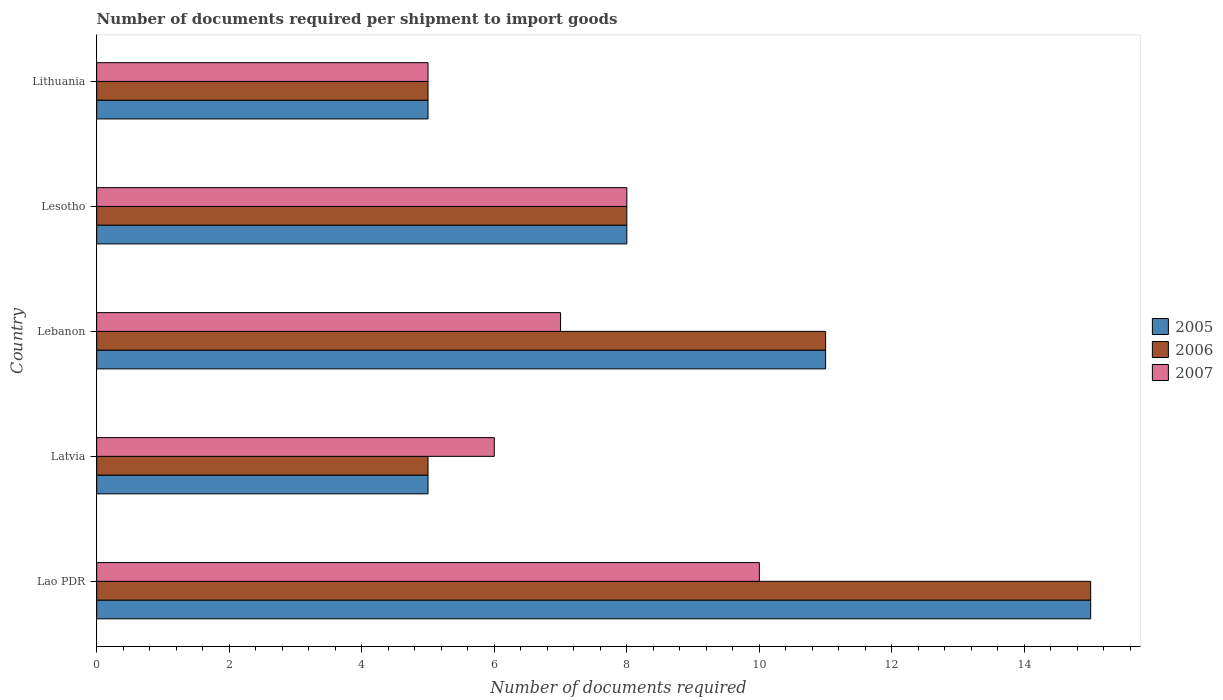How many groups of bars are there?
Keep it short and to the point. 5. How many bars are there on the 4th tick from the top?
Ensure brevity in your answer.  3. What is the label of the 1st group of bars from the top?
Your answer should be compact. Lithuania. In which country was the number of documents required per shipment to import goods in 2006 maximum?
Make the answer very short. Lao PDR. In which country was the number of documents required per shipment to import goods in 2005 minimum?
Offer a very short reply. Latvia. What is the total number of documents required per shipment to import goods in 2007 in the graph?
Your response must be concise. 36. What is the difference between the number of documents required per shipment to import goods in 2005 in Latvia and that in Lithuania?
Ensure brevity in your answer.  0. What is the difference between the number of documents required per shipment to import goods in 2007 in Lao PDR and the number of documents required per shipment to import goods in 2006 in Latvia?
Keep it short and to the point. 5. What is the average number of documents required per shipment to import goods in 2007 per country?
Offer a terse response. 7.2. What is the ratio of the number of documents required per shipment to import goods in 2005 in Latvia to that in Lithuania?
Offer a very short reply. 1. Is the difference between the number of documents required per shipment to import goods in 2006 in Latvia and Lesotho greater than the difference between the number of documents required per shipment to import goods in 2005 in Latvia and Lesotho?
Offer a very short reply. No. Is the sum of the number of documents required per shipment to import goods in 2007 in Lebanon and Lesotho greater than the maximum number of documents required per shipment to import goods in 2006 across all countries?
Ensure brevity in your answer.  No. What does the 1st bar from the top in Lithuania represents?
Provide a short and direct response. 2007. How many bars are there?
Offer a terse response. 15. What is the difference between two consecutive major ticks on the X-axis?
Provide a succinct answer. 2. Does the graph contain any zero values?
Your answer should be very brief. No. How are the legend labels stacked?
Offer a terse response. Vertical. What is the title of the graph?
Offer a very short reply. Number of documents required per shipment to import goods. What is the label or title of the X-axis?
Offer a very short reply. Number of documents required. What is the Number of documents required in 2006 in Latvia?
Make the answer very short. 5. What is the Number of documents required in 2007 in Latvia?
Your answer should be compact. 6. What is the Number of documents required of 2006 in Lebanon?
Offer a very short reply. 11. What is the Number of documents required of 2007 in Lebanon?
Your answer should be compact. 7. What is the Number of documents required of 2007 in Lesotho?
Provide a short and direct response. 8. What is the Number of documents required in 2006 in Lithuania?
Your response must be concise. 5. Across all countries, what is the maximum Number of documents required in 2006?
Offer a terse response. 15. Across all countries, what is the maximum Number of documents required of 2007?
Offer a very short reply. 10. Across all countries, what is the minimum Number of documents required of 2006?
Offer a very short reply. 5. What is the total Number of documents required of 2006 in the graph?
Make the answer very short. 44. What is the difference between the Number of documents required of 2007 in Lao PDR and that in Latvia?
Offer a terse response. 4. What is the difference between the Number of documents required of 2005 in Lao PDR and that in Lebanon?
Your answer should be very brief. 4. What is the difference between the Number of documents required of 2005 in Lao PDR and that in Lesotho?
Provide a succinct answer. 7. What is the difference between the Number of documents required in 2007 in Lao PDR and that in Lesotho?
Provide a short and direct response. 2. What is the difference between the Number of documents required in 2005 in Lao PDR and that in Lithuania?
Your response must be concise. 10. What is the difference between the Number of documents required of 2007 in Lao PDR and that in Lithuania?
Provide a short and direct response. 5. What is the difference between the Number of documents required in 2005 in Latvia and that in Lebanon?
Your answer should be compact. -6. What is the difference between the Number of documents required in 2006 in Latvia and that in Lebanon?
Make the answer very short. -6. What is the difference between the Number of documents required in 2007 in Latvia and that in Lebanon?
Your answer should be compact. -1. What is the difference between the Number of documents required in 2005 in Latvia and that in Lesotho?
Ensure brevity in your answer.  -3. What is the difference between the Number of documents required of 2006 in Latvia and that in Lesotho?
Provide a short and direct response. -3. What is the difference between the Number of documents required of 2005 in Latvia and that in Lithuania?
Provide a succinct answer. 0. What is the difference between the Number of documents required in 2005 in Lebanon and that in Lesotho?
Ensure brevity in your answer.  3. What is the difference between the Number of documents required of 2005 in Lebanon and that in Lithuania?
Your answer should be compact. 6. What is the difference between the Number of documents required of 2006 in Lebanon and that in Lithuania?
Offer a terse response. 6. What is the difference between the Number of documents required in 2007 in Lebanon and that in Lithuania?
Offer a very short reply. 2. What is the difference between the Number of documents required in 2007 in Lesotho and that in Lithuania?
Your answer should be compact. 3. What is the difference between the Number of documents required in 2005 in Lao PDR and the Number of documents required in 2006 in Latvia?
Make the answer very short. 10. What is the difference between the Number of documents required in 2006 in Lao PDR and the Number of documents required in 2007 in Latvia?
Ensure brevity in your answer.  9. What is the difference between the Number of documents required in 2005 in Lao PDR and the Number of documents required in 2006 in Lebanon?
Keep it short and to the point. 4. What is the difference between the Number of documents required in 2006 in Lao PDR and the Number of documents required in 2007 in Lebanon?
Make the answer very short. 8. What is the difference between the Number of documents required of 2005 in Lao PDR and the Number of documents required of 2006 in Lesotho?
Offer a terse response. 7. What is the difference between the Number of documents required of 2005 in Lao PDR and the Number of documents required of 2007 in Lesotho?
Keep it short and to the point. 7. What is the difference between the Number of documents required in 2006 in Lao PDR and the Number of documents required in 2007 in Lesotho?
Your answer should be compact. 7. What is the difference between the Number of documents required in 2005 in Lao PDR and the Number of documents required in 2007 in Lithuania?
Offer a terse response. 10. What is the difference between the Number of documents required in 2006 in Lao PDR and the Number of documents required in 2007 in Lithuania?
Provide a short and direct response. 10. What is the difference between the Number of documents required of 2006 in Latvia and the Number of documents required of 2007 in Lebanon?
Make the answer very short. -2. What is the difference between the Number of documents required of 2006 in Lebanon and the Number of documents required of 2007 in Lesotho?
Ensure brevity in your answer.  3. What is the difference between the Number of documents required in 2006 in Lesotho and the Number of documents required in 2007 in Lithuania?
Offer a terse response. 3. What is the average Number of documents required in 2005 per country?
Your response must be concise. 8.8. What is the average Number of documents required in 2006 per country?
Your answer should be very brief. 8.8. What is the difference between the Number of documents required in 2005 and Number of documents required in 2006 in Lao PDR?
Offer a terse response. 0. What is the difference between the Number of documents required in 2005 and Number of documents required in 2006 in Lesotho?
Your answer should be very brief. 0. What is the difference between the Number of documents required of 2005 and Number of documents required of 2007 in Lesotho?
Your response must be concise. 0. What is the difference between the Number of documents required in 2005 and Number of documents required in 2006 in Lithuania?
Offer a terse response. 0. What is the difference between the Number of documents required in 2005 and Number of documents required in 2007 in Lithuania?
Make the answer very short. 0. What is the ratio of the Number of documents required in 2005 in Lao PDR to that in Latvia?
Your response must be concise. 3. What is the ratio of the Number of documents required of 2005 in Lao PDR to that in Lebanon?
Ensure brevity in your answer.  1.36. What is the ratio of the Number of documents required in 2006 in Lao PDR to that in Lebanon?
Provide a short and direct response. 1.36. What is the ratio of the Number of documents required of 2007 in Lao PDR to that in Lebanon?
Your response must be concise. 1.43. What is the ratio of the Number of documents required of 2005 in Lao PDR to that in Lesotho?
Offer a terse response. 1.88. What is the ratio of the Number of documents required of 2006 in Lao PDR to that in Lesotho?
Offer a terse response. 1.88. What is the ratio of the Number of documents required in 2007 in Lao PDR to that in Lesotho?
Keep it short and to the point. 1.25. What is the ratio of the Number of documents required in 2005 in Latvia to that in Lebanon?
Give a very brief answer. 0.45. What is the ratio of the Number of documents required in 2006 in Latvia to that in Lebanon?
Give a very brief answer. 0.45. What is the ratio of the Number of documents required in 2006 in Latvia to that in Lesotho?
Offer a terse response. 0.62. What is the ratio of the Number of documents required of 2006 in Latvia to that in Lithuania?
Your answer should be very brief. 1. What is the ratio of the Number of documents required of 2005 in Lebanon to that in Lesotho?
Your answer should be compact. 1.38. What is the ratio of the Number of documents required in 2006 in Lebanon to that in Lesotho?
Keep it short and to the point. 1.38. What is the ratio of the Number of documents required of 2007 in Lebanon to that in Lesotho?
Provide a short and direct response. 0.88. What is the ratio of the Number of documents required in 2007 in Lebanon to that in Lithuania?
Your answer should be very brief. 1.4. What is the ratio of the Number of documents required of 2006 in Lesotho to that in Lithuania?
Give a very brief answer. 1.6. What is the difference between the highest and the second highest Number of documents required in 2007?
Ensure brevity in your answer.  2. What is the difference between the highest and the lowest Number of documents required of 2005?
Give a very brief answer. 10. What is the difference between the highest and the lowest Number of documents required of 2007?
Give a very brief answer. 5. 